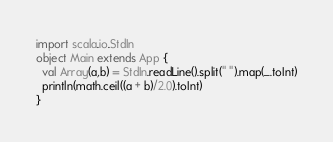<code> <loc_0><loc_0><loc_500><loc_500><_Scala_>import scala.io.StdIn
object Main extends App {
  val Array(a,b) = StdIn.readLine().split(" ").map(_.toInt)
  println(math.ceil((a + b)/2.0).toInt)
}
</code> 